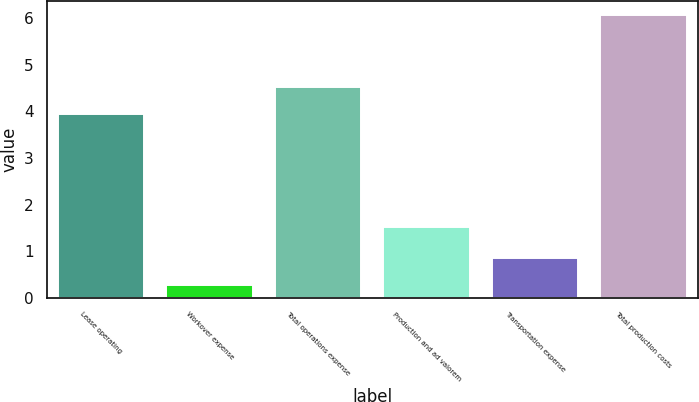<chart> <loc_0><loc_0><loc_500><loc_500><bar_chart><fcel>Lease operating<fcel>Workover expense<fcel>Total operations expense<fcel>Production and ad valorem<fcel>Transportation expense<fcel>Total production costs<nl><fcel>3.94<fcel>0.27<fcel>4.52<fcel>1.52<fcel>0.85<fcel>6.06<nl></chart> 